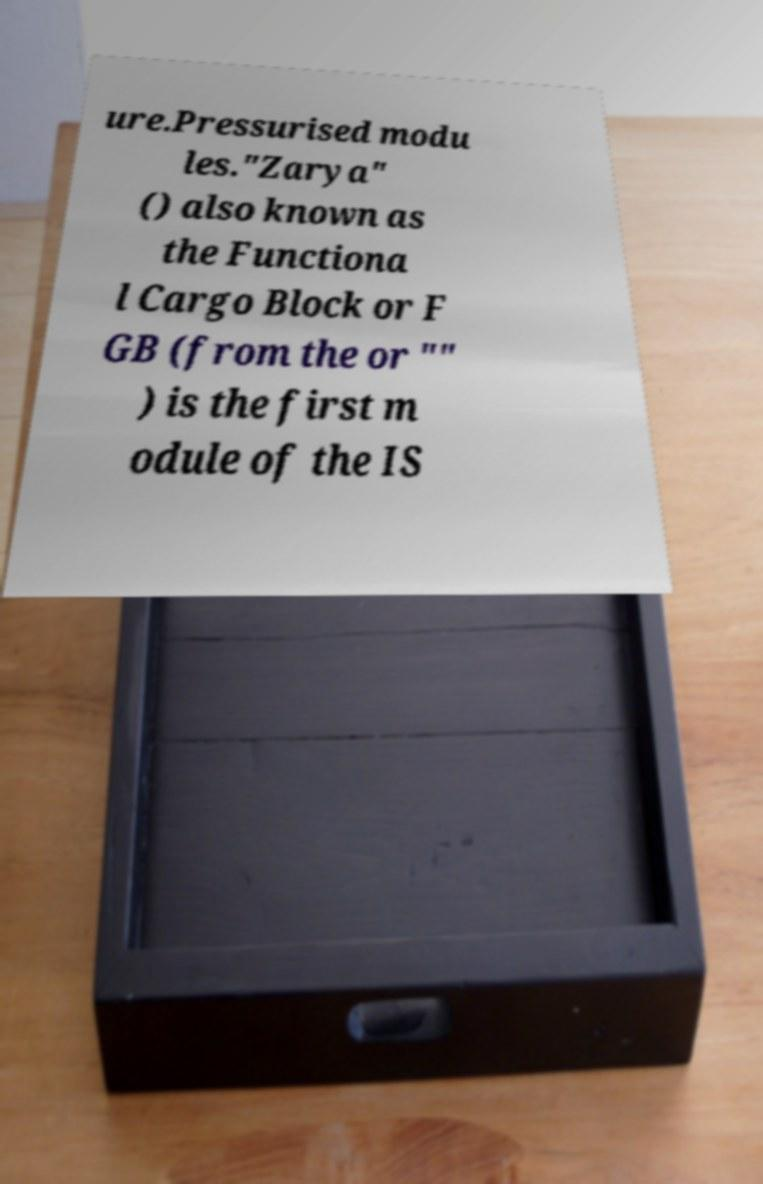Could you assist in decoding the text presented in this image and type it out clearly? ure.Pressurised modu les."Zarya" () also known as the Functiona l Cargo Block or F GB (from the or "" ) is the first m odule of the IS 